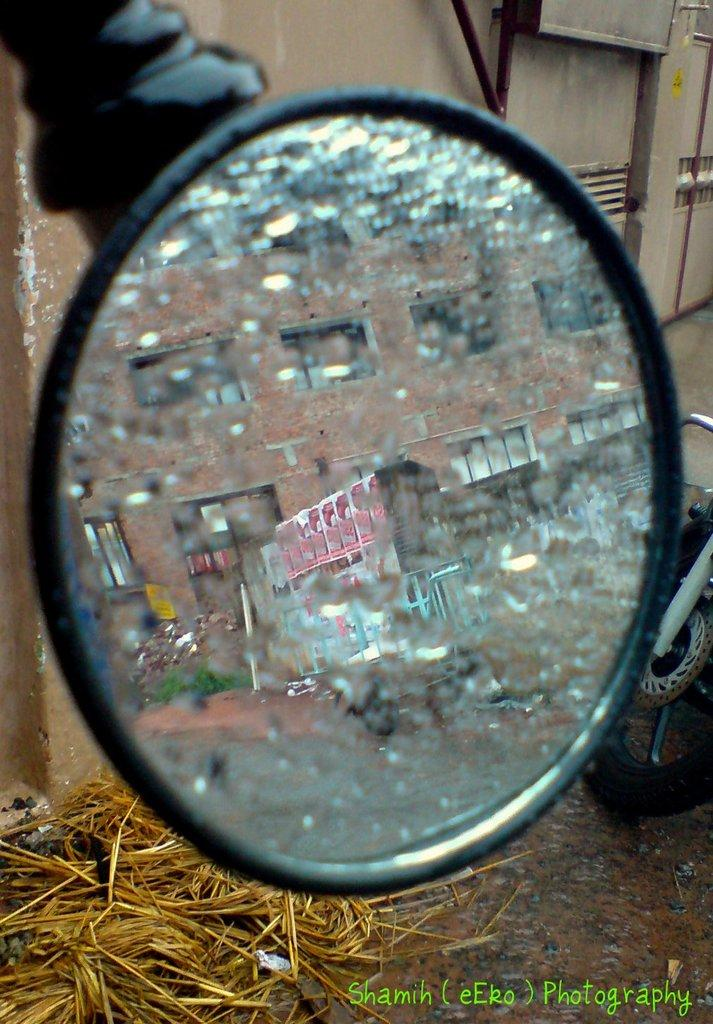What is the main object in the middle of the image? There is a mirror in the middle of the image. What can be seen on the right side of the image? There is a wheel of a bike on the right side of the image. What type of vegetation is visible in the image? There is dry grass visible in the image. Where is the watermark located in the image? The watermark is at the bottom of the image. What type of animal is wearing trousers in the image? There are no animals wearing trousers in the image. What color are the trousers worn by the animal in the image? Since there are no animals wearing trousers in the image, we cannot determine the color of the trousers. 